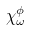Convert formula to latex. <formula><loc_0><loc_0><loc_500><loc_500>\chi _ { \omega } ^ { \phi }</formula> 